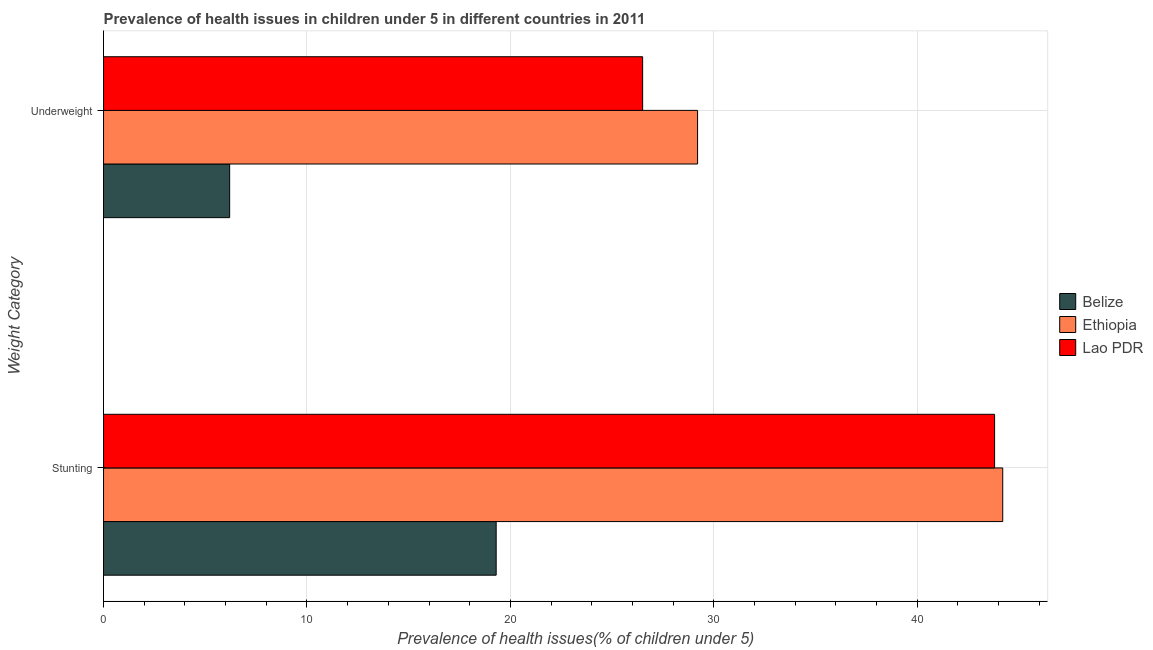Are the number of bars on each tick of the Y-axis equal?
Your response must be concise. Yes. What is the label of the 2nd group of bars from the top?
Offer a very short reply. Stunting. What is the percentage of underweight children in Belize?
Provide a succinct answer. 6.2. Across all countries, what is the maximum percentage of underweight children?
Give a very brief answer. 29.2. Across all countries, what is the minimum percentage of stunted children?
Your response must be concise. 19.3. In which country was the percentage of stunted children maximum?
Make the answer very short. Ethiopia. In which country was the percentage of underweight children minimum?
Your answer should be compact. Belize. What is the total percentage of stunted children in the graph?
Give a very brief answer. 107.3. What is the difference between the percentage of stunted children in Belize and that in Lao PDR?
Your response must be concise. -24.5. What is the difference between the percentage of underweight children in Belize and the percentage of stunted children in Ethiopia?
Offer a terse response. -38. What is the average percentage of stunted children per country?
Keep it short and to the point. 35.77. What is the difference between the percentage of underweight children and percentage of stunted children in Belize?
Give a very brief answer. -13.1. In how many countries, is the percentage of underweight children greater than 38 %?
Provide a short and direct response. 0. What is the ratio of the percentage of stunted children in Ethiopia to that in Lao PDR?
Your answer should be compact. 1.01. What does the 3rd bar from the top in Underweight represents?
Your response must be concise. Belize. What does the 1st bar from the bottom in Stunting represents?
Your response must be concise. Belize. How many bars are there?
Your answer should be compact. 6. What is the difference between two consecutive major ticks on the X-axis?
Make the answer very short. 10. Does the graph contain grids?
Provide a succinct answer. Yes. How are the legend labels stacked?
Your answer should be very brief. Vertical. What is the title of the graph?
Your answer should be very brief. Prevalence of health issues in children under 5 in different countries in 2011. What is the label or title of the X-axis?
Your answer should be very brief. Prevalence of health issues(% of children under 5). What is the label or title of the Y-axis?
Your answer should be compact. Weight Category. What is the Prevalence of health issues(% of children under 5) in Belize in Stunting?
Ensure brevity in your answer.  19.3. What is the Prevalence of health issues(% of children under 5) of Ethiopia in Stunting?
Provide a short and direct response. 44.2. What is the Prevalence of health issues(% of children under 5) in Lao PDR in Stunting?
Your response must be concise. 43.8. What is the Prevalence of health issues(% of children under 5) in Belize in Underweight?
Ensure brevity in your answer.  6.2. What is the Prevalence of health issues(% of children under 5) in Ethiopia in Underweight?
Offer a terse response. 29.2. What is the Prevalence of health issues(% of children under 5) of Lao PDR in Underweight?
Your answer should be compact. 26.5. Across all Weight Category, what is the maximum Prevalence of health issues(% of children under 5) of Belize?
Your answer should be compact. 19.3. Across all Weight Category, what is the maximum Prevalence of health issues(% of children under 5) in Ethiopia?
Provide a succinct answer. 44.2. Across all Weight Category, what is the maximum Prevalence of health issues(% of children under 5) of Lao PDR?
Your answer should be very brief. 43.8. Across all Weight Category, what is the minimum Prevalence of health issues(% of children under 5) in Belize?
Your answer should be compact. 6.2. Across all Weight Category, what is the minimum Prevalence of health issues(% of children under 5) of Ethiopia?
Offer a terse response. 29.2. Across all Weight Category, what is the minimum Prevalence of health issues(% of children under 5) of Lao PDR?
Ensure brevity in your answer.  26.5. What is the total Prevalence of health issues(% of children under 5) in Ethiopia in the graph?
Your answer should be compact. 73.4. What is the total Prevalence of health issues(% of children under 5) in Lao PDR in the graph?
Your response must be concise. 70.3. What is the difference between the Prevalence of health issues(% of children under 5) of Ethiopia in Stunting and that in Underweight?
Your answer should be very brief. 15. What is the difference between the Prevalence of health issues(% of children under 5) of Belize in Stunting and the Prevalence of health issues(% of children under 5) of Ethiopia in Underweight?
Give a very brief answer. -9.9. What is the average Prevalence of health issues(% of children under 5) of Belize per Weight Category?
Provide a succinct answer. 12.75. What is the average Prevalence of health issues(% of children under 5) in Ethiopia per Weight Category?
Offer a terse response. 36.7. What is the average Prevalence of health issues(% of children under 5) in Lao PDR per Weight Category?
Offer a terse response. 35.15. What is the difference between the Prevalence of health issues(% of children under 5) of Belize and Prevalence of health issues(% of children under 5) of Ethiopia in Stunting?
Give a very brief answer. -24.9. What is the difference between the Prevalence of health issues(% of children under 5) of Belize and Prevalence of health issues(% of children under 5) of Lao PDR in Stunting?
Your answer should be compact. -24.5. What is the difference between the Prevalence of health issues(% of children under 5) in Ethiopia and Prevalence of health issues(% of children under 5) in Lao PDR in Stunting?
Your response must be concise. 0.4. What is the difference between the Prevalence of health issues(% of children under 5) in Belize and Prevalence of health issues(% of children under 5) in Ethiopia in Underweight?
Offer a terse response. -23. What is the difference between the Prevalence of health issues(% of children under 5) in Belize and Prevalence of health issues(% of children under 5) in Lao PDR in Underweight?
Provide a succinct answer. -20.3. What is the ratio of the Prevalence of health issues(% of children under 5) of Belize in Stunting to that in Underweight?
Your answer should be compact. 3.11. What is the ratio of the Prevalence of health issues(% of children under 5) of Ethiopia in Stunting to that in Underweight?
Keep it short and to the point. 1.51. What is the ratio of the Prevalence of health issues(% of children under 5) of Lao PDR in Stunting to that in Underweight?
Your answer should be very brief. 1.65. What is the difference between the highest and the second highest Prevalence of health issues(% of children under 5) of Belize?
Offer a terse response. 13.1. What is the difference between the highest and the lowest Prevalence of health issues(% of children under 5) of Belize?
Provide a succinct answer. 13.1. What is the difference between the highest and the lowest Prevalence of health issues(% of children under 5) of Ethiopia?
Offer a very short reply. 15. What is the difference between the highest and the lowest Prevalence of health issues(% of children under 5) in Lao PDR?
Offer a terse response. 17.3. 